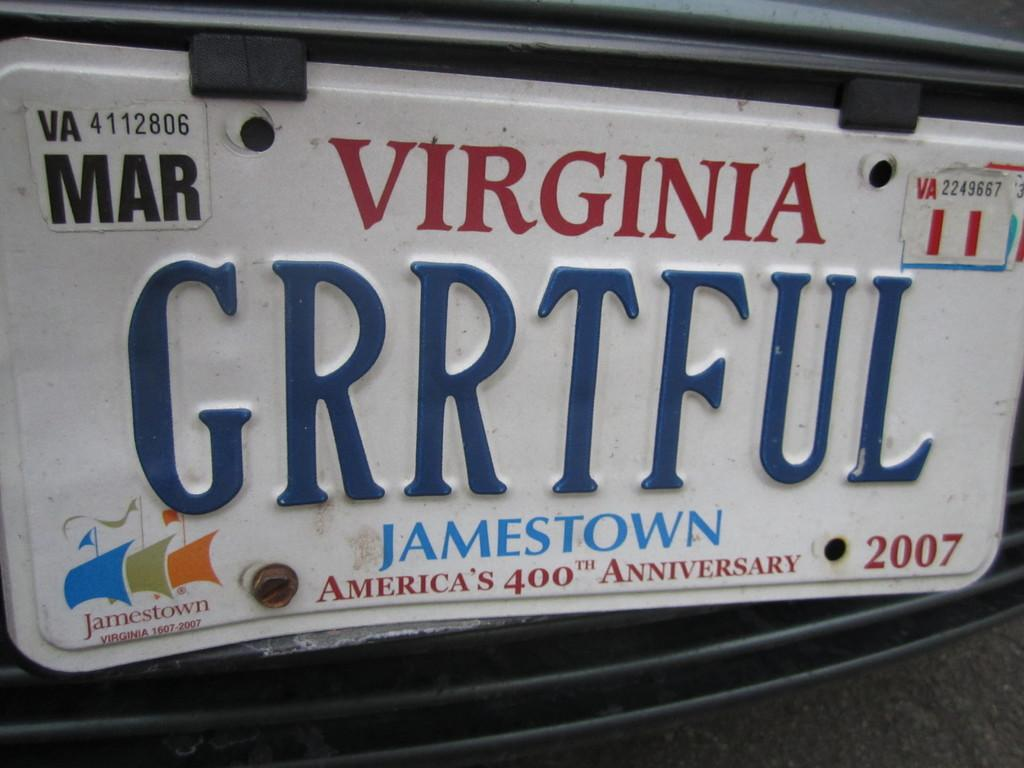<image>
Write a terse but informative summary of the picture. A metal Virginia state license plate from jamestown on the bottom of it. 